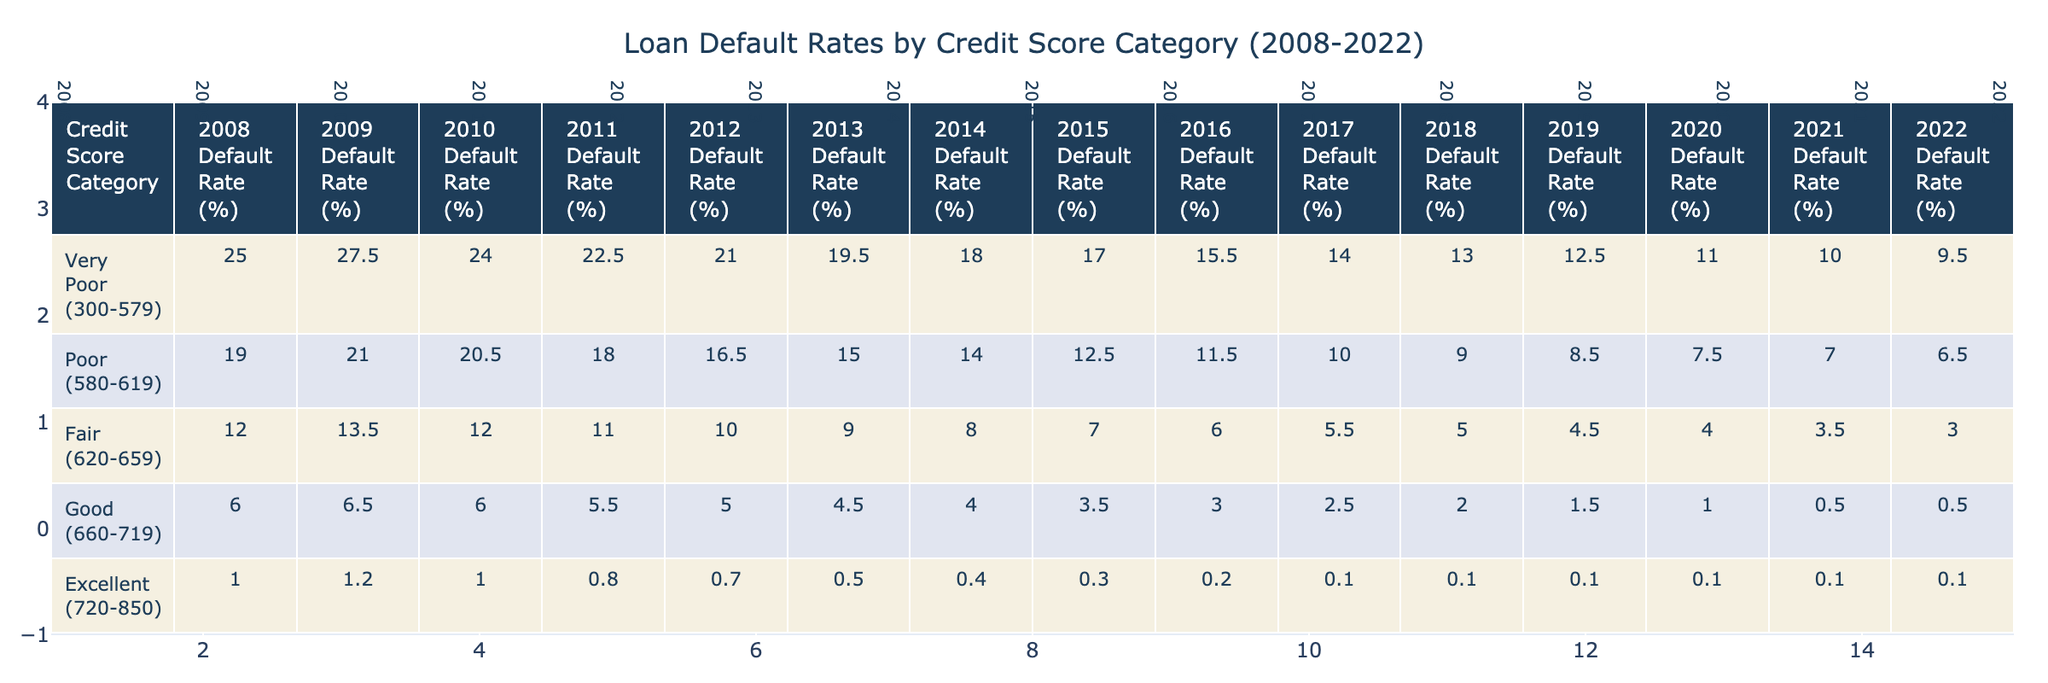What was the default rate for the "Very Poor (300-579)" category in 2010? The table shows that the default rate for the "Very Poor (300-579)" category in 2010 is 24.0%.
Answer: 24.0% What is the default rate in 2022 for the "Poor (580-619)" category? According to the table, the default rate for the "Poor (580-619)" category in 2022 is 6.5%.
Answer: 6.5% Which credit score category had the highest default rate in 2008? By examining the table, it is evident that the "Very Poor (300-579)" category had the highest default rate in 2008 at 25.0%.
Answer: Very Poor (300-579) What is the difference in the default rates between the "Good (660-719)" and "Excellent (720-850)" categories in 2019? In 2019, the default rate for "Good (660-719)" is 1.5% and for "Excellent (720-850)" is 0.1%. The difference is 1.5% - 0.1% = 1.4%.
Answer: 1.4% Is it true that the default rate for the "Fair (620-659)" category decreased every year from 2008 to 2022? Evaluating the table, the default rates for the "Fair (620-659)" category show a decrease from 12.0% in 2008 to 3.0% in 2022, confirming that the rate decreased every year.
Answer: Yes What was the average default rate for the "Good (660-719)" category from 2008 to 2022? To calculate the average, sum the default rates for the "Good (660-719)" category: (6.0 + 6.5 + 6.0 + 5.5 + 5.0 + 4.5 + 4.0 + 3.5 + 3.0 + 2.5 + 2.0 + 1.5 + 1.0 + 0.5 + 0.5) = 56.5. There are 15 data points, so the average is 56.5 / 15 = 3.77%.
Answer: 3.77% What was the lowest default rate recorded in the table and in what year? The table indicates that the lowest default rate recorded is 0.1% for the "Excellent (720-850)" category, which occurred in the years 2018, 2019, 2020, 2021, and 2022.
Answer: 0.1% In which year did the "Poor (580-619)" category see a notable drop in its default rate compared to the previous year? Assessing the table, the "Poor (580-619)" category saw a notable drop from 12.5% in 2015 to 11.5% in 2016, indicating a significant decline in that year.
Answer: 2016 